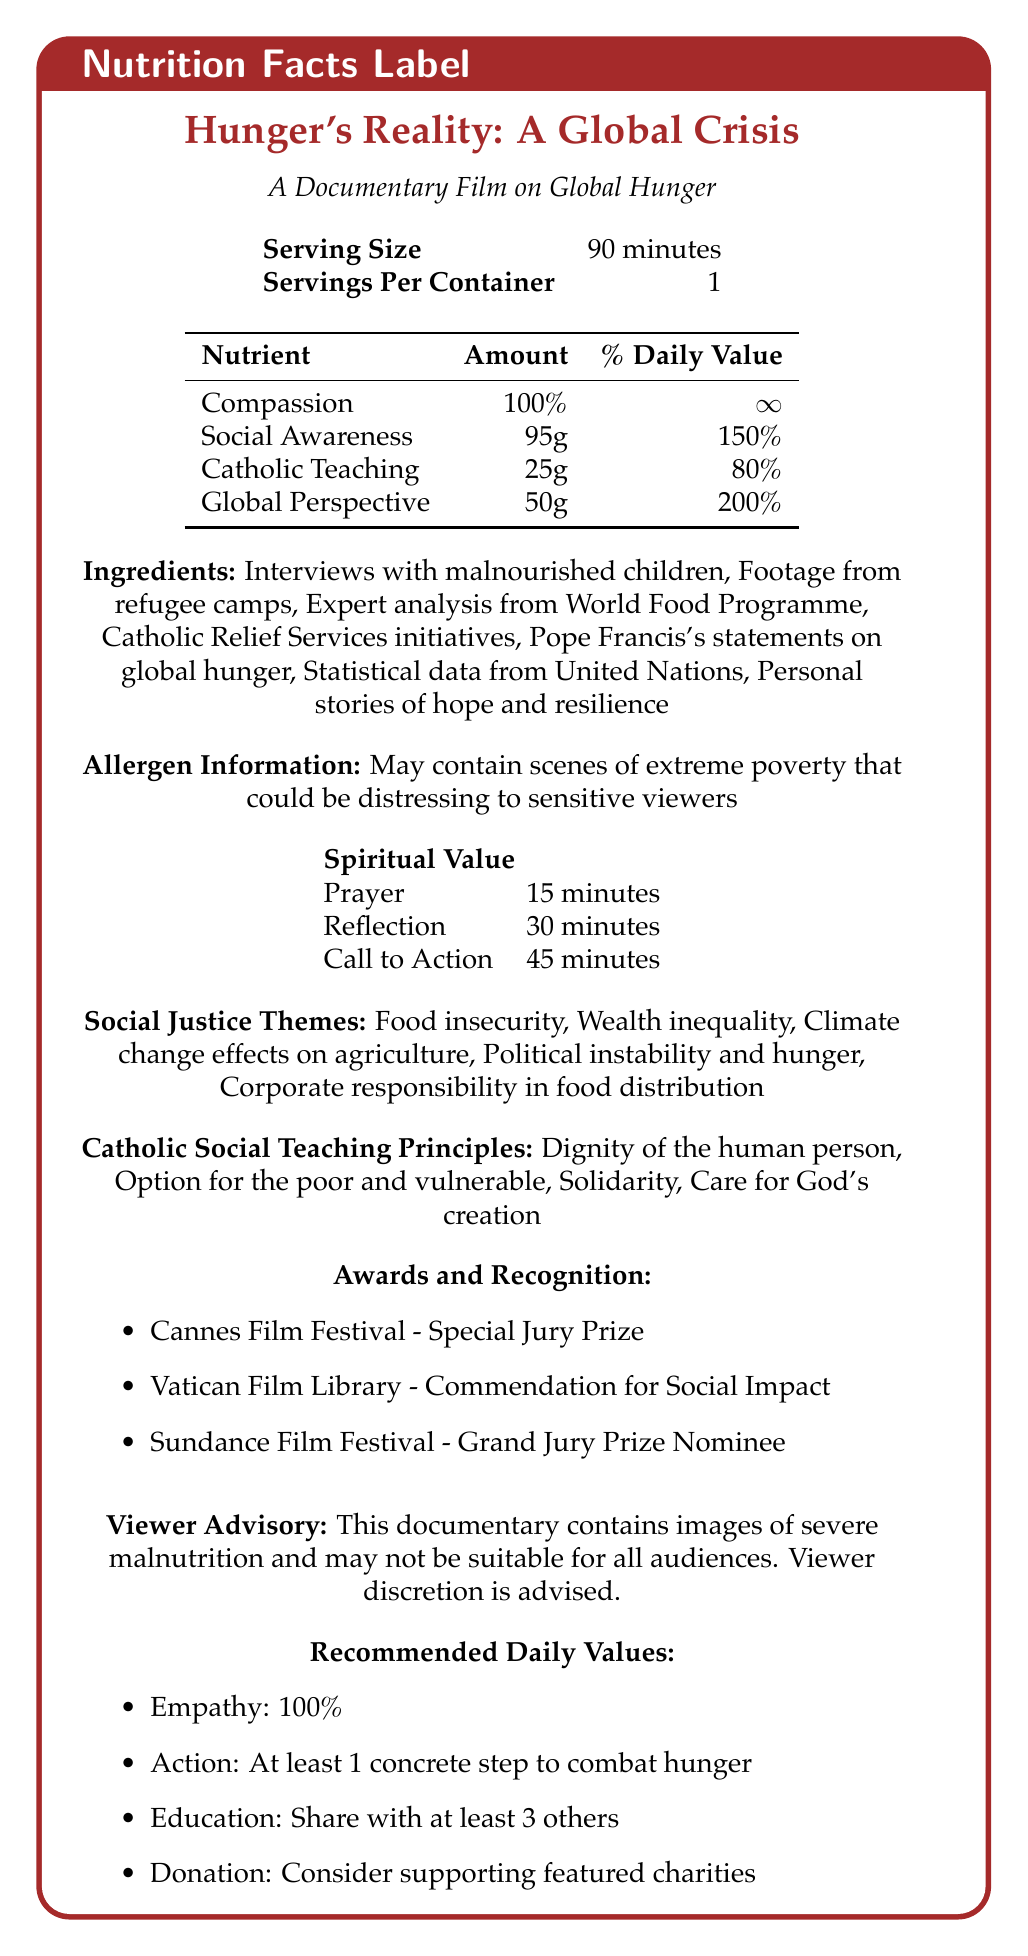What is the serving size of the documentary? The document states that the serving size of the documentary is 90 minutes.
Answer: 90 minutes How many servings are in one container of this documentary? According to the document, there is 1 serving per container.
Answer: 1 What nutrient has the highest % Daily Value? Compassion is listed with a % Daily Value of ∞, which is the highest.
Answer: Compassion List three ingredients used in making this documentary. The document lists these as the first three ingredients.
Answer: Interviews with malnourished children, Footage from refugee camps, Expert analysis from World Food Programme What is the allergen information provided for this documentary? The allergen information warns that the documentary may contain distressing scenes of poverty.
Answer: May contain scenes of extreme poverty that could be distressing to sensitive viewers How many minutes of reflection are recommended for the spiritual value? The document specifies 30 minutes for reflection.
Answer: 30 minutes Which of the following awards did the documentary receive? A. Cannes Film Festival - Best Picture B. Sundance Film Festival - Audience Choice Award C. Cannes Film Festival - Special Jury Prize D. Vatican Film Library - Commendation for Visual Excellence The document states the film received the Cannes Film Festival - Special Jury Prize.
Answer: C Which principle of Catholic Social Teaching is mentioned in the document? A. Dignity of the human person B. Promotion of Peace C. Charity and Justice D. Participation The document lists the dignity of the human person as one of the Catholic Social Teaching Principles.
Answer: A Does the documentary have a high visual impact? Under cinematography, it states that the visual impact is high.
Answer: Yes Describe the main idea of this document. The explanation explains the layout, content, and the intention behind presenting the information in this specific format.
Answer: This document is a creative take on a Nutrition Facts Label for a documentary film titled "Hunger's Reality: A Global Crisis." It highlights the film's duration, main themes, ingredients, awards, and its impact on social awareness and Catholic teachings. What exact year was the documentary released? The document does not provide the specific year of release.
Answer: Not enough information 